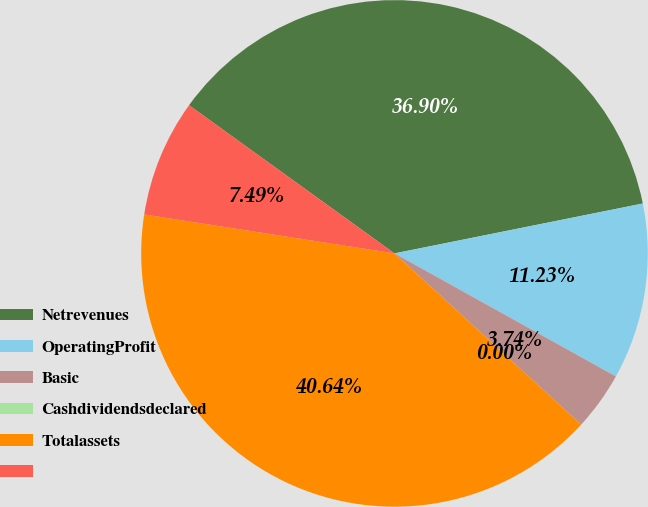Convert chart to OTSL. <chart><loc_0><loc_0><loc_500><loc_500><pie_chart><fcel>Netrevenues<fcel>OperatingProfit<fcel>Basic<fcel>Cashdividendsdeclared<fcel>Totalassets<fcel>Unnamed: 5<nl><fcel>36.9%<fcel>11.23%<fcel>3.74%<fcel>0.0%<fcel>40.64%<fcel>7.49%<nl></chart> 